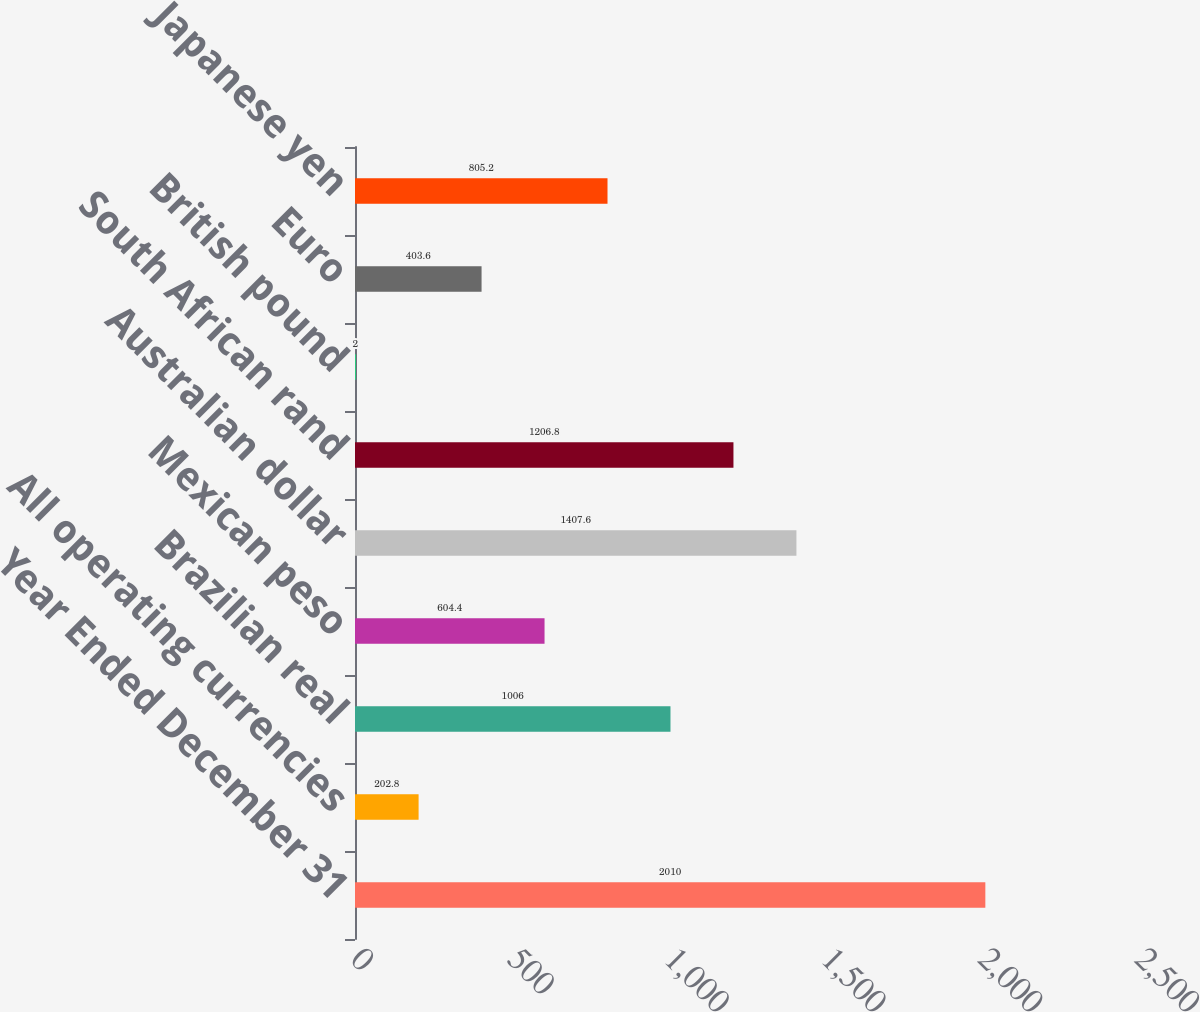Convert chart. <chart><loc_0><loc_0><loc_500><loc_500><bar_chart><fcel>Year Ended December 31<fcel>All operating currencies<fcel>Brazilian real<fcel>Mexican peso<fcel>Australian dollar<fcel>South African rand<fcel>British pound<fcel>Euro<fcel>Japanese yen<nl><fcel>2010<fcel>202.8<fcel>1006<fcel>604.4<fcel>1407.6<fcel>1206.8<fcel>2<fcel>403.6<fcel>805.2<nl></chart> 